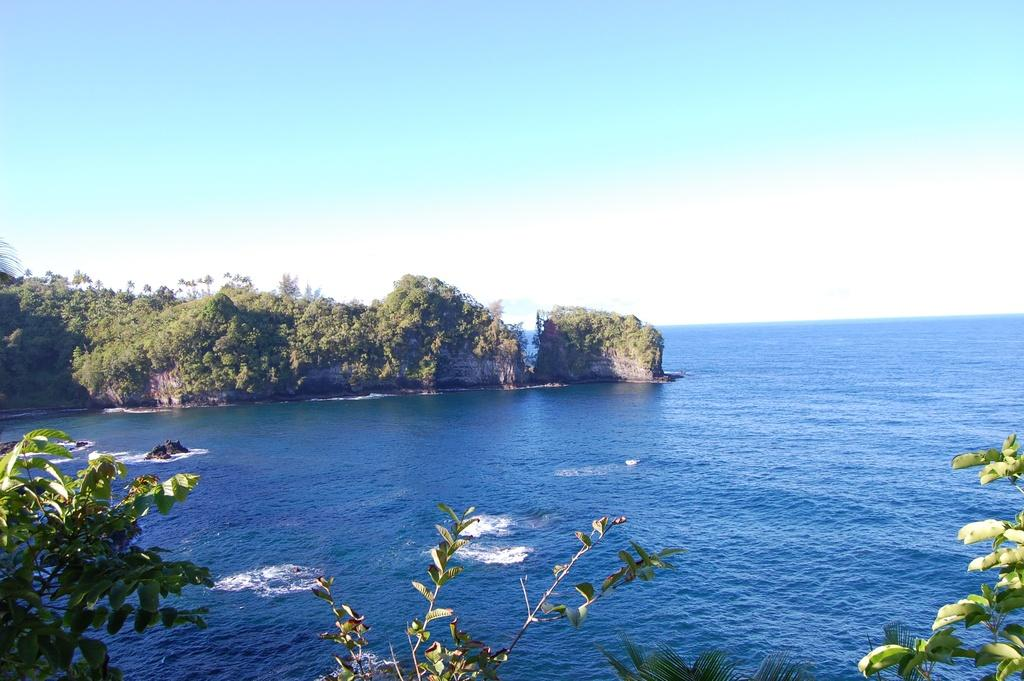What type of natural environment is depicted in the image? The image features a sea and a rock hill covered with trees. What is the terrain like in the image? The rock hill is covered with trees, and there are other plants in the front of the rock hill. Can you describe the vegetation in the image? The rock hill is covered with trees, and there are other plants in the front of the rock hill. What type of pet can be seen playing with a needle in the image? There is no pet or needle present in the image; it features a sea and a rock hill covered with trees. 